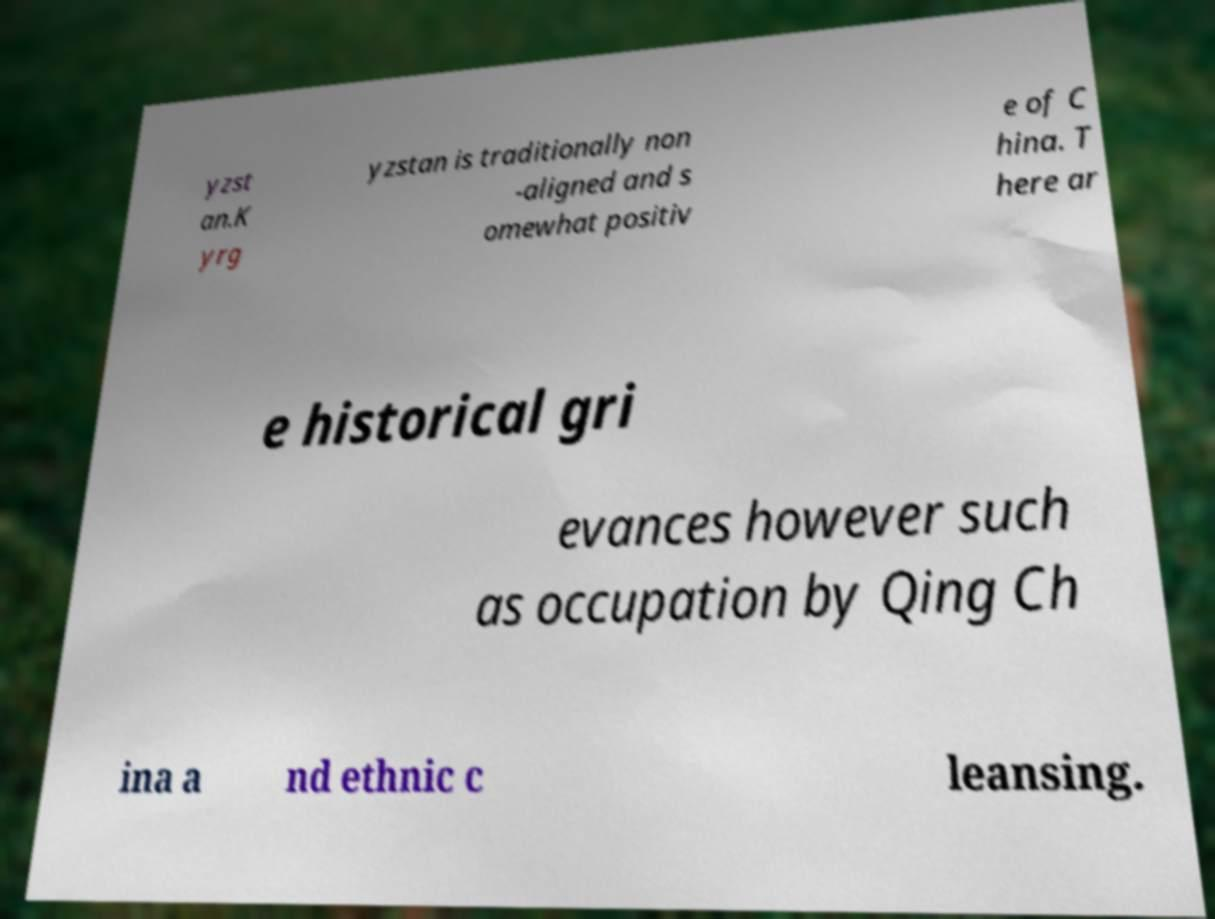Please identify and transcribe the text found in this image. yzst an.K yrg yzstan is traditionally non -aligned and s omewhat positiv e of C hina. T here ar e historical gri evances however such as occupation by Qing Ch ina a nd ethnic c leansing. 